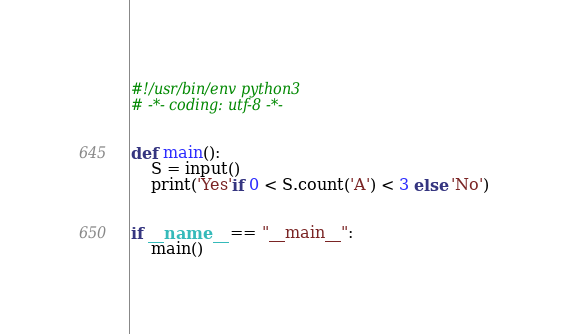Convert code to text. <code><loc_0><loc_0><loc_500><loc_500><_Python_>#!/usr/bin/env python3
# -*- coding: utf-8 -*-


def main():
    S = input()
    print('Yes'if 0 < S.count('A') < 3 else 'No')


if __name__ == "__main__":
    main()
</code> 